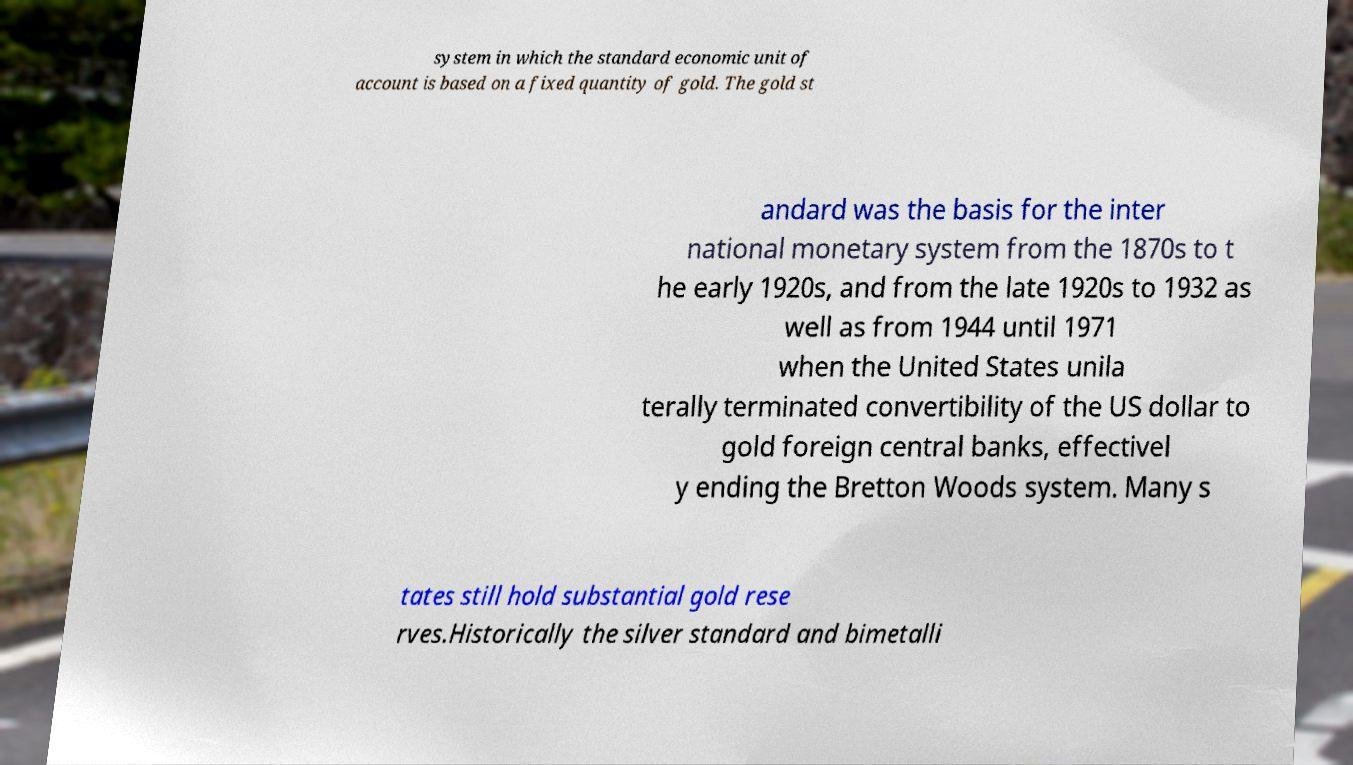What messages or text are displayed in this image? I need them in a readable, typed format. system in which the standard economic unit of account is based on a fixed quantity of gold. The gold st andard was the basis for the inter national monetary system from the 1870s to t he early 1920s, and from the late 1920s to 1932 as well as from 1944 until 1971 when the United States unila terally terminated convertibility of the US dollar to gold foreign central banks, effectivel y ending the Bretton Woods system. Many s tates still hold substantial gold rese rves.Historically the silver standard and bimetalli 